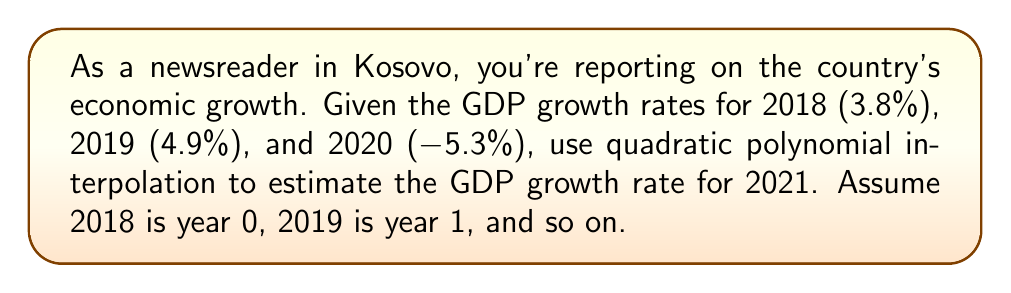Provide a solution to this math problem. Let's approach this step-by-step:

1) We'll use the quadratic polynomial form: $f(x) = ax^2 + bx + c$

2) Our data points are:
   $(0, 3.8)$, $(1, 4.9)$, $(2, -5.3)$

3) Substituting these into our polynomial:
   $3.8 = c$
   $4.9 = a + b + 3.8$
   $-5.3 = 4a + 2b + 3.8$

4) From the first equation:
   $c = 3.8$

5) From the second equation:
   $a + b = 1.1$

6) Substituting into the third equation:
   $-5.3 = 4a + 2(1.1 - a) + 3.8$
   $-5.3 = 4a + 2.2 - 2a + 3.8$
   $-5.3 = 2a + 6$
   $-11.3 = 2a$
   $a = -5.65$

7) Now we can find $b$:
   $b = 1.1 - a = 1.1 - (-5.65) = 6.75$

8) Our polynomial is:
   $f(x) = -5.65x^2 + 6.75x + 3.8$

9) To estimate 2021 (year 3), we calculate $f(3)$:
   $f(3) = -5.65(3)^2 + 6.75(3) + 3.8$
   $     = -5.65(9) + 20.25 + 3.8$
   $     = -50.85 + 20.25 + 3.8$
   $     = -26.8$
Answer: -26.8% 